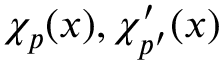Convert formula to latex. <formula><loc_0><loc_0><loc_500><loc_500>\chi _ { p } ( x ) , \chi _ { p ^ { \prime } } ^ { \prime } ( x )</formula> 